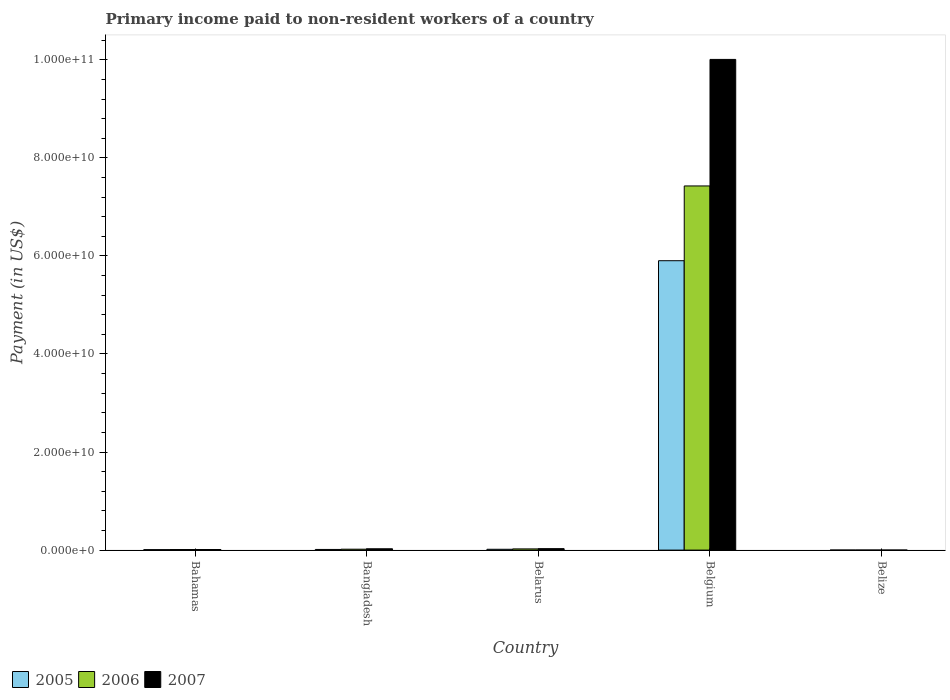Are the number of bars on each tick of the X-axis equal?
Provide a short and direct response. Yes. How many bars are there on the 1st tick from the left?
Provide a succinct answer. 3. How many bars are there on the 5th tick from the right?
Your answer should be compact. 3. What is the label of the 1st group of bars from the left?
Keep it short and to the point. Bahamas. What is the amount paid to workers in 2007 in Belize?
Keep it short and to the point. 6.97e+06. Across all countries, what is the maximum amount paid to workers in 2007?
Your response must be concise. 1.00e+11. Across all countries, what is the minimum amount paid to workers in 2007?
Offer a terse response. 6.97e+06. In which country was the amount paid to workers in 2007 maximum?
Your answer should be compact. Belgium. In which country was the amount paid to workers in 2007 minimum?
Your response must be concise. Belize. What is the total amount paid to workers in 2005 in the graph?
Offer a terse response. 5.94e+1. What is the difference between the amount paid to workers in 2005 in Bahamas and that in Bangladesh?
Provide a succinct answer. -3.82e+07. What is the difference between the amount paid to workers in 2005 in Bahamas and the amount paid to workers in 2006 in Belarus?
Your answer should be very brief. -1.50e+08. What is the average amount paid to workers in 2006 per country?
Keep it short and to the point. 1.50e+1. What is the difference between the amount paid to workers of/in 2005 and amount paid to workers of/in 2006 in Bangladesh?
Provide a short and direct response. -4.93e+07. What is the ratio of the amount paid to workers in 2006 in Bangladesh to that in Belize?
Keep it short and to the point. 18.26. Is the amount paid to workers in 2007 in Bahamas less than that in Belgium?
Offer a terse response. Yes. Is the difference between the amount paid to workers in 2005 in Belarus and Belize greater than the difference between the amount paid to workers in 2006 in Belarus and Belize?
Provide a succinct answer. No. What is the difference between the highest and the second highest amount paid to workers in 2006?
Provide a succinct answer. -7.40e+1. What is the difference between the highest and the lowest amount paid to workers in 2005?
Keep it short and to the point. 5.90e+1. What does the 1st bar from the left in Belarus represents?
Your answer should be very brief. 2005. Is it the case that in every country, the sum of the amount paid to workers in 2006 and amount paid to workers in 2007 is greater than the amount paid to workers in 2005?
Provide a succinct answer. Yes. How many bars are there?
Ensure brevity in your answer.  15. Are all the bars in the graph horizontal?
Provide a succinct answer. No. How many countries are there in the graph?
Keep it short and to the point. 5. Are the values on the major ticks of Y-axis written in scientific E-notation?
Provide a succinct answer. Yes. Does the graph contain any zero values?
Give a very brief answer. No. How many legend labels are there?
Your response must be concise. 3. What is the title of the graph?
Provide a short and direct response. Primary income paid to non-resident workers of a country. What is the label or title of the X-axis?
Your response must be concise. Country. What is the label or title of the Y-axis?
Make the answer very short. Payment (in US$). What is the Payment (in US$) in 2005 in Bahamas?
Offer a terse response. 9.70e+07. What is the Payment (in US$) of 2006 in Bahamas?
Keep it short and to the point. 1.19e+08. What is the Payment (in US$) in 2007 in Bahamas?
Ensure brevity in your answer.  1.21e+08. What is the Payment (in US$) of 2005 in Bangladesh?
Your answer should be compact. 1.35e+08. What is the Payment (in US$) of 2006 in Bangladesh?
Ensure brevity in your answer.  1.84e+08. What is the Payment (in US$) of 2007 in Bangladesh?
Your answer should be compact. 2.72e+08. What is the Payment (in US$) in 2005 in Belarus?
Your answer should be very brief. 1.68e+08. What is the Payment (in US$) of 2006 in Belarus?
Provide a succinct answer. 2.47e+08. What is the Payment (in US$) of 2007 in Belarus?
Your answer should be very brief. 2.97e+08. What is the Payment (in US$) of 2005 in Belgium?
Ensure brevity in your answer.  5.90e+1. What is the Payment (in US$) in 2006 in Belgium?
Offer a very short reply. 7.43e+1. What is the Payment (in US$) of 2007 in Belgium?
Ensure brevity in your answer.  1.00e+11. What is the Payment (in US$) of 2005 in Belize?
Provide a short and direct response. 6.78e+06. What is the Payment (in US$) in 2006 in Belize?
Provide a short and direct response. 1.01e+07. What is the Payment (in US$) in 2007 in Belize?
Keep it short and to the point. 6.97e+06. Across all countries, what is the maximum Payment (in US$) in 2005?
Ensure brevity in your answer.  5.90e+1. Across all countries, what is the maximum Payment (in US$) of 2006?
Your answer should be compact. 7.43e+1. Across all countries, what is the maximum Payment (in US$) of 2007?
Offer a very short reply. 1.00e+11. Across all countries, what is the minimum Payment (in US$) of 2005?
Give a very brief answer. 6.78e+06. Across all countries, what is the minimum Payment (in US$) in 2006?
Provide a succinct answer. 1.01e+07. Across all countries, what is the minimum Payment (in US$) in 2007?
Offer a very short reply. 6.97e+06. What is the total Payment (in US$) of 2005 in the graph?
Your response must be concise. 5.94e+1. What is the total Payment (in US$) in 2006 in the graph?
Offer a terse response. 7.48e+1. What is the total Payment (in US$) of 2007 in the graph?
Make the answer very short. 1.01e+11. What is the difference between the Payment (in US$) of 2005 in Bahamas and that in Bangladesh?
Provide a short and direct response. -3.82e+07. What is the difference between the Payment (in US$) of 2006 in Bahamas and that in Bangladesh?
Offer a very short reply. -6.50e+07. What is the difference between the Payment (in US$) in 2007 in Bahamas and that in Bangladesh?
Your response must be concise. -1.50e+08. What is the difference between the Payment (in US$) of 2005 in Bahamas and that in Belarus?
Make the answer very short. -7.14e+07. What is the difference between the Payment (in US$) of 2006 in Bahamas and that in Belarus?
Provide a succinct answer. -1.27e+08. What is the difference between the Payment (in US$) in 2007 in Bahamas and that in Belarus?
Your answer should be compact. -1.76e+08. What is the difference between the Payment (in US$) of 2005 in Bahamas and that in Belgium?
Offer a terse response. -5.89e+1. What is the difference between the Payment (in US$) of 2006 in Bahamas and that in Belgium?
Offer a terse response. -7.42e+1. What is the difference between the Payment (in US$) in 2007 in Bahamas and that in Belgium?
Your response must be concise. -1.00e+11. What is the difference between the Payment (in US$) in 2005 in Bahamas and that in Belize?
Provide a short and direct response. 9.02e+07. What is the difference between the Payment (in US$) in 2006 in Bahamas and that in Belize?
Provide a short and direct response. 1.09e+08. What is the difference between the Payment (in US$) of 2007 in Bahamas and that in Belize?
Provide a succinct answer. 1.14e+08. What is the difference between the Payment (in US$) of 2005 in Bangladesh and that in Belarus?
Ensure brevity in your answer.  -3.32e+07. What is the difference between the Payment (in US$) of 2006 in Bangladesh and that in Belarus?
Your answer should be compact. -6.22e+07. What is the difference between the Payment (in US$) of 2007 in Bangladesh and that in Belarus?
Your answer should be compact. -2.54e+07. What is the difference between the Payment (in US$) of 2005 in Bangladesh and that in Belgium?
Your response must be concise. -5.89e+1. What is the difference between the Payment (in US$) in 2006 in Bangladesh and that in Belgium?
Offer a terse response. -7.41e+1. What is the difference between the Payment (in US$) of 2007 in Bangladesh and that in Belgium?
Keep it short and to the point. -9.98e+1. What is the difference between the Payment (in US$) of 2005 in Bangladesh and that in Belize?
Ensure brevity in your answer.  1.28e+08. What is the difference between the Payment (in US$) in 2006 in Bangladesh and that in Belize?
Provide a short and direct response. 1.74e+08. What is the difference between the Payment (in US$) in 2007 in Bangladesh and that in Belize?
Provide a succinct answer. 2.65e+08. What is the difference between the Payment (in US$) in 2005 in Belarus and that in Belgium?
Provide a succinct answer. -5.89e+1. What is the difference between the Payment (in US$) in 2006 in Belarus and that in Belgium?
Provide a short and direct response. -7.40e+1. What is the difference between the Payment (in US$) in 2007 in Belarus and that in Belgium?
Offer a very short reply. -9.98e+1. What is the difference between the Payment (in US$) of 2005 in Belarus and that in Belize?
Your response must be concise. 1.62e+08. What is the difference between the Payment (in US$) in 2006 in Belarus and that in Belize?
Offer a terse response. 2.36e+08. What is the difference between the Payment (in US$) of 2007 in Belarus and that in Belize?
Provide a succinct answer. 2.90e+08. What is the difference between the Payment (in US$) of 2005 in Belgium and that in Belize?
Provide a short and direct response. 5.90e+1. What is the difference between the Payment (in US$) in 2006 in Belgium and that in Belize?
Your response must be concise. 7.43e+1. What is the difference between the Payment (in US$) of 2007 in Belgium and that in Belize?
Your answer should be very brief. 1.00e+11. What is the difference between the Payment (in US$) of 2005 in Bahamas and the Payment (in US$) of 2006 in Bangladesh?
Offer a terse response. -8.74e+07. What is the difference between the Payment (in US$) of 2005 in Bahamas and the Payment (in US$) of 2007 in Bangladesh?
Ensure brevity in your answer.  -1.75e+08. What is the difference between the Payment (in US$) of 2006 in Bahamas and the Payment (in US$) of 2007 in Bangladesh?
Your response must be concise. -1.52e+08. What is the difference between the Payment (in US$) in 2005 in Bahamas and the Payment (in US$) in 2006 in Belarus?
Give a very brief answer. -1.50e+08. What is the difference between the Payment (in US$) of 2005 in Bahamas and the Payment (in US$) of 2007 in Belarus?
Ensure brevity in your answer.  -2.00e+08. What is the difference between the Payment (in US$) of 2006 in Bahamas and the Payment (in US$) of 2007 in Belarus?
Keep it short and to the point. -1.78e+08. What is the difference between the Payment (in US$) in 2005 in Bahamas and the Payment (in US$) in 2006 in Belgium?
Your answer should be very brief. -7.42e+1. What is the difference between the Payment (in US$) of 2005 in Bahamas and the Payment (in US$) of 2007 in Belgium?
Your response must be concise. -1.00e+11. What is the difference between the Payment (in US$) of 2006 in Bahamas and the Payment (in US$) of 2007 in Belgium?
Provide a short and direct response. -1.00e+11. What is the difference between the Payment (in US$) in 2005 in Bahamas and the Payment (in US$) in 2006 in Belize?
Give a very brief answer. 8.69e+07. What is the difference between the Payment (in US$) in 2005 in Bahamas and the Payment (in US$) in 2007 in Belize?
Your answer should be compact. 9.00e+07. What is the difference between the Payment (in US$) in 2006 in Bahamas and the Payment (in US$) in 2007 in Belize?
Ensure brevity in your answer.  1.12e+08. What is the difference between the Payment (in US$) of 2005 in Bangladesh and the Payment (in US$) of 2006 in Belarus?
Offer a terse response. -1.11e+08. What is the difference between the Payment (in US$) of 2005 in Bangladesh and the Payment (in US$) of 2007 in Belarus?
Ensure brevity in your answer.  -1.62e+08. What is the difference between the Payment (in US$) in 2006 in Bangladesh and the Payment (in US$) in 2007 in Belarus?
Give a very brief answer. -1.13e+08. What is the difference between the Payment (in US$) in 2005 in Bangladesh and the Payment (in US$) in 2006 in Belgium?
Offer a terse response. -7.41e+1. What is the difference between the Payment (in US$) of 2005 in Bangladesh and the Payment (in US$) of 2007 in Belgium?
Your answer should be compact. -1.00e+11. What is the difference between the Payment (in US$) of 2006 in Bangladesh and the Payment (in US$) of 2007 in Belgium?
Give a very brief answer. -9.99e+1. What is the difference between the Payment (in US$) of 2005 in Bangladesh and the Payment (in US$) of 2006 in Belize?
Give a very brief answer. 1.25e+08. What is the difference between the Payment (in US$) of 2005 in Bangladesh and the Payment (in US$) of 2007 in Belize?
Keep it short and to the point. 1.28e+08. What is the difference between the Payment (in US$) in 2006 in Bangladesh and the Payment (in US$) in 2007 in Belize?
Keep it short and to the point. 1.77e+08. What is the difference between the Payment (in US$) of 2005 in Belarus and the Payment (in US$) of 2006 in Belgium?
Provide a succinct answer. -7.41e+1. What is the difference between the Payment (in US$) in 2005 in Belarus and the Payment (in US$) in 2007 in Belgium?
Ensure brevity in your answer.  -9.99e+1. What is the difference between the Payment (in US$) in 2006 in Belarus and the Payment (in US$) in 2007 in Belgium?
Your answer should be very brief. -9.98e+1. What is the difference between the Payment (in US$) in 2005 in Belarus and the Payment (in US$) in 2006 in Belize?
Your response must be concise. 1.58e+08. What is the difference between the Payment (in US$) of 2005 in Belarus and the Payment (in US$) of 2007 in Belize?
Your answer should be very brief. 1.61e+08. What is the difference between the Payment (in US$) of 2006 in Belarus and the Payment (in US$) of 2007 in Belize?
Your response must be concise. 2.40e+08. What is the difference between the Payment (in US$) of 2005 in Belgium and the Payment (in US$) of 2006 in Belize?
Provide a short and direct response. 5.90e+1. What is the difference between the Payment (in US$) of 2005 in Belgium and the Payment (in US$) of 2007 in Belize?
Keep it short and to the point. 5.90e+1. What is the difference between the Payment (in US$) of 2006 in Belgium and the Payment (in US$) of 2007 in Belize?
Offer a terse response. 7.43e+1. What is the average Payment (in US$) of 2005 per country?
Make the answer very short. 1.19e+1. What is the average Payment (in US$) of 2006 per country?
Your response must be concise. 1.50e+1. What is the average Payment (in US$) of 2007 per country?
Give a very brief answer. 2.02e+1. What is the difference between the Payment (in US$) of 2005 and Payment (in US$) of 2006 in Bahamas?
Provide a succinct answer. -2.24e+07. What is the difference between the Payment (in US$) in 2005 and Payment (in US$) in 2007 in Bahamas?
Keep it short and to the point. -2.43e+07. What is the difference between the Payment (in US$) of 2006 and Payment (in US$) of 2007 in Bahamas?
Keep it short and to the point. -1.88e+06. What is the difference between the Payment (in US$) of 2005 and Payment (in US$) of 2006 in Bangladesh?
Offer a terse response. -4.93e+07. What is the difference between the Payment (in US$) in 2005 and Payment (in US$) in 2007 in Bangladesh?
Your answer should be compact. -1.37e+08. What is the difference between the Payment (in US$) of 2006 and Payment (in US$) of 2007 in Bangladesh?
Your answer should be compact. -8.73e+07. What is the difference between the Payment (in US$) of 2005 and Payment (in US$) of 2006 in Belarus?
Your answer should be very brief. -7.82e+07. What is the difference between the Payment (in US$) in 2005 and Payment (in US$) in 2007 in Belarus?
Your response must be concise. -1.29e+08. What is the difference between the Payment (in US$) in 2006 and Payment (in US$) in 2007 in Belarus?
Your answer should be very brief. -5.05e+07. What is the difference between the Payment (in US$) of 2005 and Payment (in US$) of 2006 in Belgium?
Your answer should be very brief. -1.52e+1. What is the difference between the Payment (in US$) in 2005 and Payment (in US$) in 2007 in Belgium?
Give a very brief answer. -4.11e+1. What is the difference between the Payment (in US$) of 2006 and Payment (in US$) of 2007 in Belgium?
Your answer should be very brief. -2.58e+1. What is the difference between the Payment (in US$) in 2005 and Payment (in US$) in 2006 in Belize?
Offer a terse response. -3.32e+06. What is the difference between the Payment (in US$) in 2005 and Payment (in US$) in 2007 in Belize?
Your response must be concise. -1.86e+05. What is the difference between the Payment (in US$) in 2006 and Payment (in US$) in 2007 in Belize?
Your answer should be compact. 3.13e+06. What is the ratio of the Payment (in US$) of 2005 in Bahamas to that in Bangladesh?
Your answer should be compact. 0.72. What is the ratio of the Payment (in US$) in 2006 in Bahamas to that in Bangladesh?
Offer a very short reply. 0.65. What is the ratio of the Payment (in US$) of 2007 in Bahamas to that in Bangladesh?
Offer a terse response. 0.45. What is the ratio of the Payment (in US$) of 2005 in Bahamas to that in Belarus?
Give a very brief answer. 0.58. What is the ratio of the Payment (in US$) in 2006 in Bahamas to that in Belarus?
Your answer should be compact. 0.48. What is the ratio of the Payment (in US$) in 2007 in Bahamas to that in Belarus?
Keep it short and to the point. 0.41. What is the ratio of the Payment (in US$) in 2005 in Bahamas to that in Belgium?
Offer a very short reply. 0. What is the ratio of the Payment (in US$) in 2006 in Bahamas to that in Belgium?
Your response must be concise. 0. What is the ratio of the Payment (in US$) of 2007 in Bahamas to that in Belgium?
Your response must be concise. 0. What is the ratio of the Payment (in US$) of 2005 in Bahamas to that in Belize?
Your answer should be compact. 14.3. What is the ratio of the Payment (in US$) in 2006 in Bahamas to that in Belize?
Give a very brief answer. 11.82. What is the ratio of the Payment (in US$) in 2007 in Bahamas to that in Belize?
Offer a terse response. 17.41. What is the ratio of the Payment (in US$) of 2005 in Bangladesh to that in Belarus?
Your answer should be compact. 0.8. What is the ratio of the Payment (in US$) in 2006 in Bangladesh to that in Belarus?
Offer a very short reply. 0.75. What is the ratio of the Payment (in US$) of 2007 in Bangladesh to that in Belarus?
Your answer should be compact. 0.91. What is the ratio of the Payment (in US$) in 2005 in Bangladesh to that in Belgium?
Your answer should be compact. 0. What is the ratio of the Payment (in US$) of 2006 in Bangladesh to that in Belgium?
Give a very brief answer. 0. What is the ratio of the Payment (in US$) in 2007 in Bangladesh to that in Belgium?
Provide a short and direct response. 0. What is the ratio of the Payment (in US$) in 2005 in Bangladesh to that in Belize?
Offer a terse response. 19.93. What is the ratio of the Payment (in US$) in 2006 in Bangladesh to that in Belize?
Keep it short and to the point. 18.26. What is the ratio of the Payment (in US$) in 2007 in Bangladesh to that in Belize?
Offer a very short reply. 39. What is the ratio of the Payment (in US$) of 2005 in Belarus to that in Belgium?
Provide a succinct answer. 0. What is the ratio of the Payment (in US$) of 2006 in Belarus to that in Belgium?
Your answer should be very brief. 0. What is the ratio of the Payment (in US$) of 2007 in Belarus to that in Belgium?
Provide a succinct answer. 0. What is the ratio of the Payment (in US$) in 2005 in Belarus to that in Belize?
Offer a terse response. 24.83. What is the ratio of the Payment (in US$) of 2006 in Belarus to that in Belize?
Offer a terse response. 24.41. What is the ratio of the Payment (in US$) of 2007 in Belarus to that in Belize?
Offer a very short reply. 42.65. What is the ratio of the Payment (in US$) of 2005 in Belgium to that in Belize?
Give a very brief answer. 8704.96. What is the ratio of the Payment (in US$) in 2006 in Belgium to that in Belize?
Give a very brief answer. 7353.89. What is the ratio of the Payment (in US$) of 2007 in Belgium to that in Belize?
Keep it short and to the point. 1.44e+04. What is the difference between the highest and the second highest Payment (in US$) of 2005?
Make the answer very short. 5.89e+1. What is the difference between the highest and the second highest Payment (in US$) of 2006?
Provide a short and direct response. 7.40e+1. What is the difference between the highest and the second highest Payment (in US$) in 2007?
Your answer should be very brief. 9.98e+1. What is the difference between the highest and the lowest Payment (in US$) of 2005?
Your answer should be very brief. 5.90e+1. What is the difference between the highest and the lowest Payment (in US$) of 2006?
Offer a terse response. 7.43e+1. What is the difference between the highest and the lowest Payment (in US$) in 2007?
Provide a succinct answer. 1.00e+11. 